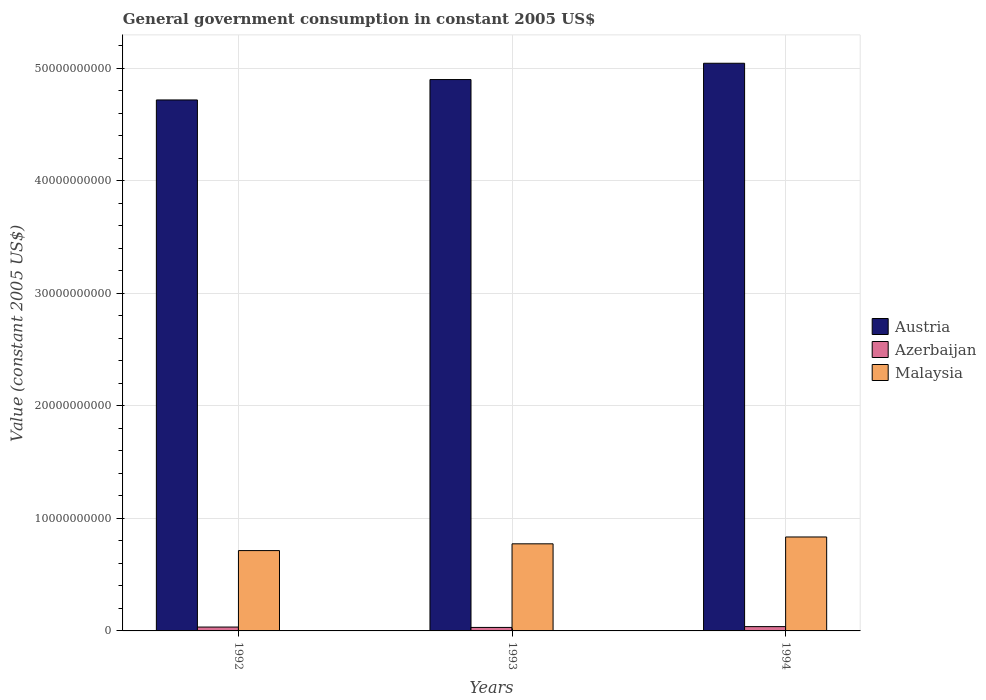How many different coloured bars are there?
Your answer should be compact. 3. Are the number of bars on each tick of the X-axis equal?
Your answer should be compact. Yes. How many bars are there on the 1st tick from the right?
Offer a terse response. 3. What is the government conusmption in Austria in 1993?
Offer a very short reply. 4.90e+1. Across all years, what is the maximum government conusmption in Azerbaijan?
Offer a terse response. 3.83e+08. Across all years, what is the minimum government conusmption in Malaysia?
Ensure brevity in your answer.  7.14e+09. In which year was the government conusmption in Azerbaijan maximum?
Your response must be concise. 1994. In which year was the government conusmption in Azerbaijan minimum?
Offer a very short reply. 1993. What is the total government conusmption in Azerbaijan in the graph?
Your answer should be very brief. 1.04e+09. What is the difference between the government conusmption in Azerbaijan in 1993 and that in 1994?
Your response must be concise. -7.25e+07. What is the difference between the government conusmption in Austria in 1992 and the government conusmption in Azerbaijan in 1993?
Keep it short and to the point. 4.69e+1. What is the average government conusmption in Austria per year?
Your answer should be compact. 4.89e+1. In the year 1992, what is the difference between the government conusmption in Azerbaijan and government conusmption in Malaysia?
Provide a succinct answer. -6.79e+09. What is the ratio of the government conusmption in Azerbaijan in 1992 to that in 1993?
Make the answer very short. 1.11. What is the difference between the highest and the second highest government conusmption in Malaysia?
Your response must be concise. 6.09e+08. What is the difference between the highest and the lowest government conusmption in Austria?
Your answer should be compact. 3.26e+09. In how many years, is the government conusmption in Azerbaijan greater than the average government conusmption in Azerbaijan taken over all years?
Ensure brevity in your answer.  1. Is the sum of the government conusmption in Austria in 1993 and 1994 greater than the maximum government conusmption in Malaysia across all years?
Your response must be concise. Yes. What does the 3rd bar from the left in 1992 represents?
Your answer should be compact. Malaysia. What does the 1st bar from the right in 1993 represents?
Offer a terse response. Malaysia. How many bars are there?
Your response must be concise. 9. Where does the legend appear in the graph?
Your response must be concise. Center right. How many legend labels are there?
Offer a terse response. 3. What is the title of the graph?
Provide a short and direct response. General government consumption in constant 2005 US$. Does "Suriname" appear as one of the legend labels in the graph?
Your answer should be compact. No. What is the label or title of the Y-axis?
Keep it short and to the point. Value (constant 2005 US$). What is the Value (constant 2005 US$) in Austria in 1992?
Provide a short and direct response. 4.72e+1. What is the Value (constant 2005 US$) of Azerbaijan in 1992?
Ensure brevity in your answer.  3.44e+08. What is the Value (constant 2005 US$) of Malaysia in 1992?
Keep it short and to the point. 7.14e+09. What is the Value (constant 2005 US$) in Austria in 1993?
Keep it short and to the point. 4.90e+1. What is the Value (constant 2005 US$) of Azerbaijan in 1993?
Ensure brevity in your answer.  3.10e+08. What is the Value (constant 2005 US$) of Malaysia in 1993?
Give a very brief answer. 7.74e+09. What is the Value (constant 2005 US$) of Austria in 1994?
Offer a very short reply. 5.04e+1. What is the Value (constant 2005 US$) of Azerbaijan in 1994?
Your response must be concise. 3.83e+08. What is the Value (constant 2005 US$) in Malaysia in 1994?
Offer a terse response. 8.35e+09. Across all years, what is the maximum Value (constant 2005 US$) of Austria?
Your answer should be very brief. 5.04e+1. Across all years, what is the maximum Value (constant 2005 US$) in Azerbaijan?
Your answer should be compact. 3.83e+08. Across all years, what is the maximum Value (constant 2005 US$) of Malaysia?
Give a very brief answer. 8.35e+09. Across all years, what is the minimum Value (constant 2005 US$) in Austria?
Your answer should be very brief. 4.72e+1. Across all years, what is the minimum Value (constant 2005 US$) in Azerbaijan?
Make the answer very short. 3.10e+08. Across all years, what is the minimum Value (constant 2005 US$) in Malaysia?
Give a very brief answer. 7.14e+09. What is the total Value (constant 2005 US$) of Austria in the graph?
Your answer should be compact. 1.47e+11. What is the total Value (constant 2005 US$) in Azerbaijan in the graph?
Keep it short and to the point. 1.04e+09. What is the total Value (constant 2005 US$) of Malaysia in the graph?
Make the answer very short. 2.32e+1. What is the difference between the Value (constant 2005 US$) in Austria in 1992 and that in 1993?
Offer a very short reply. -1.81e+09. What is the difference between the Value (constant 2005 US$) of Azerbaijan in 1992 and that in 1993?
Keep it short and to the point. 3.38e+07. What is the difference between the Value (constant 2005 US$) of Malaysia in 1992 and that in 1993?
Your answer should be compact. -6.01e+08. What is the difference between the Value (constant 2005 US$) in Austria in 1992 and that in 1994?
Provide a succinct answer. -3.26e+09. What is the difference between the Value (constant 2005 US$) in Azerbaijan in 1992 and that in 1994?
Make the answer very short. -3.87e+07. What is the difference between the Value (constant 2005 US$) of Malaysia in 1992 and that in 1994?
Ensure brevity in your answer.  -1.21e+09. What is the difference between the Value (constant 2005 US$) in Austria in 1993 and that in 1994?
Your answer should be compact. -1.45e+09. What is the difference between the Value (constant 2005 US$) of Azerbaijan in 1993 and that in 1994?
Your response must be concise. -7.25e+07. What is the difference between the Value (constant 2005 US$) in Malaysia in 1993 and that in 1994?
Give a very brief answer. -6.09e+08. What is the difference between the Value (constant 2005 US$) in Austria in 1992 and the Value (constant 2005 US$) in Azerbaijan in 1993?
Offer a very short reply. 4.69e+1. What is the difference between the Value (constant 2005 US$) in Austria in 1992 and the Value (constant 2005 US$) in Malaysia in 1993?
Give a very brief answer. 3.94e+1. What is the difference between the Value (constant 2005 US$) in Azerbaijan in 1992 and the Value (constant 2005 US$) in Malaysia in 1993?
Your answer should be very brief. -7.39e+09. What is the difference between the Value (constant 2005 US$) of Austria in 1992 and the Value (constant 2005 US$) of Azerbaijan in 1994?
Ensure brevity in your answer.  4.68e+1. What is the difference between the Value (constant 2005 US$) in Austria in 1992 and the Value (constant 2005 US$) in Malaysia in 1994?
Your answer should be very brief. 3.88e+1. What is the difference between the Value (constant 2005 US$) of Azerbaijan in 1992 and the Value (constant 2005 US$) of Malaysia in 1994?
Your response must be concise. -8.00e+09. What is the difference between the Value (constant 2005 US$) in Austria in 1993 and the Value (constant 2005 US$) in Azerbaijan in 1994?
Your answer should be compact. 4.86e+1. What is the difference between the Value (constant 2005 US$) of Austria in 1993 and the Value (constant 2005 US$) of Malaysia in 1994?
Your answer should be very brief. 4.06e+1. What is the difference between the Value (constant 2005 US$) of Azerbaijan in 1993 and the Value (constant 2005 US$) of Malaysia in 1994?
Offer a terse response. -8.04e+09. What is the average Value (constant 2005 US$) in Austria per year?
Your response must be concise. 4.89e+1. What is the average Value (constant 2005 US$) of Azerbaijan per year?
Keep it short and to the point. 3.45e+08. What is the average Value (constant 2005 US$) in Malaysia per year?
Keep it short and to the point. 7.74e+09. In the year 1992, what is the difference between the Value (constant 2005 US$) in Austria and Value (constant 2005 US$) in Azerbaijan?
Your answer should be very brief. 4.68e+1. In the year 1992, what is the difference between the Value (constant 2005 US$) of Austria and Value (constant 2005 US$) of Malaysia?
Offer a very short reply. 4.00e+1. In the year 1992, what is the difference between the Value (constant 2005 US$) in Azerbaijan and Value (constant 2005 US$) in Malaysia?
Provide a short and direct response. -6.79e+09. In the year 1993, what is the difference between the Value (constant 2005 US$) of Austria and Value (constant 2005 US$) of Azerbaijan?
Provide a succinct answer. 4.87e+1. In the year 1993, what is the difference between the Value (constant 2005 US$) in Austria and Value (constant 2005 US$) in Malaysia?
Ensure brevity in your answer.  4.12e+1. In the year 1993, what is the difference between the Value (constant 2005 US$) in Azerbaijan and Value (constant 2005 US$) in Malaysia?
Your response must be concise. -7.43e+09. In the year 1994, what is the difference between the Value (constant 2005 US$) of Austria and Value (constant 2005 US$) of Azerbaijan?
Your answer should be compact. 5.01e+1. In the year 1994, what is the difference between the Value (constant 2005 US$) of Austria and Value (constant 2005 US$) of Malaysia?
Give a very brief answer. 4.21e+1. In the year 1994, what is the difference between the Value (constant 2005 US$) in Azerbaijan and Value (constant 2005 US$) in Malaysia?
Keep it short and to the point. -7.96e+09. What is the ratio of the Value (constant 2005 US$) of Austria in 1992 to that in 1993?
Keep it short and to the point. 0.96. What is the ratio of the Value (constant 2005 US$) of Azerbaijan in 1992 to that in 1993?
Provide a succinct answer. 1.11. What is the ratio of the Value (constant 2005 US$) of Malaysia in 1992 to that in 1993?
Make the answer very short. 0.92. What is the ratio of the Value (constant 2005 US$) in Austria in 1992 to that in 1994?
Provide a succinct answer. 0.94. What is the ratio of the Value (constant 2005 US$) of Azerbaijan in 1992 to that in 1994?
Your response must be concise. 0.9. What is the ratio of the Value (constant 2005 US$) in Malaysia in 1992 to that in 1994?
Give a very brief answer. 0.85. What is the ratio of the Value (constant 2005 US$) in Austria in 1993 to that in 1994?
Your answer should be compact. 0.97. What is the ratio of the Value (constant 2005 US$) in Azerbaijan in 1993 to that in 1994?
Provide a short and direct response. 0.81. What is the ratio of the Value (constant 2005 US$) of Malaysia in 1993 to that in 1994?
Your answer should be very brief. 0.93. What is the difference between the highest and the second highest Value (constant 2005 US$) of Austria?
Offer a terse response. 1.45e+09. What is the difference between the highest and the second highest Value (constant 2005 US$) of Azerbaijan?
Your response must be concise. 3.87e+07. What is the difference between the highest and the second highest Value (constant 2005 US$) of Malaysia?
Your response must be concise. 6.09e+08. What is the difference between the highest and the lowest Value (constant 2005 US$) of Austria?
Your response must be concise. 3.26e+09. What is the difference between the highest and the lowest Value (constant 2005 US$) of Azerbaijan?
Offer a very short reply. 7.25e+07. What is the difference between the highest and the lowest Value (constant 2005 US$) of Malaysia?
Provide a short and direct response. 1.21e+09. 